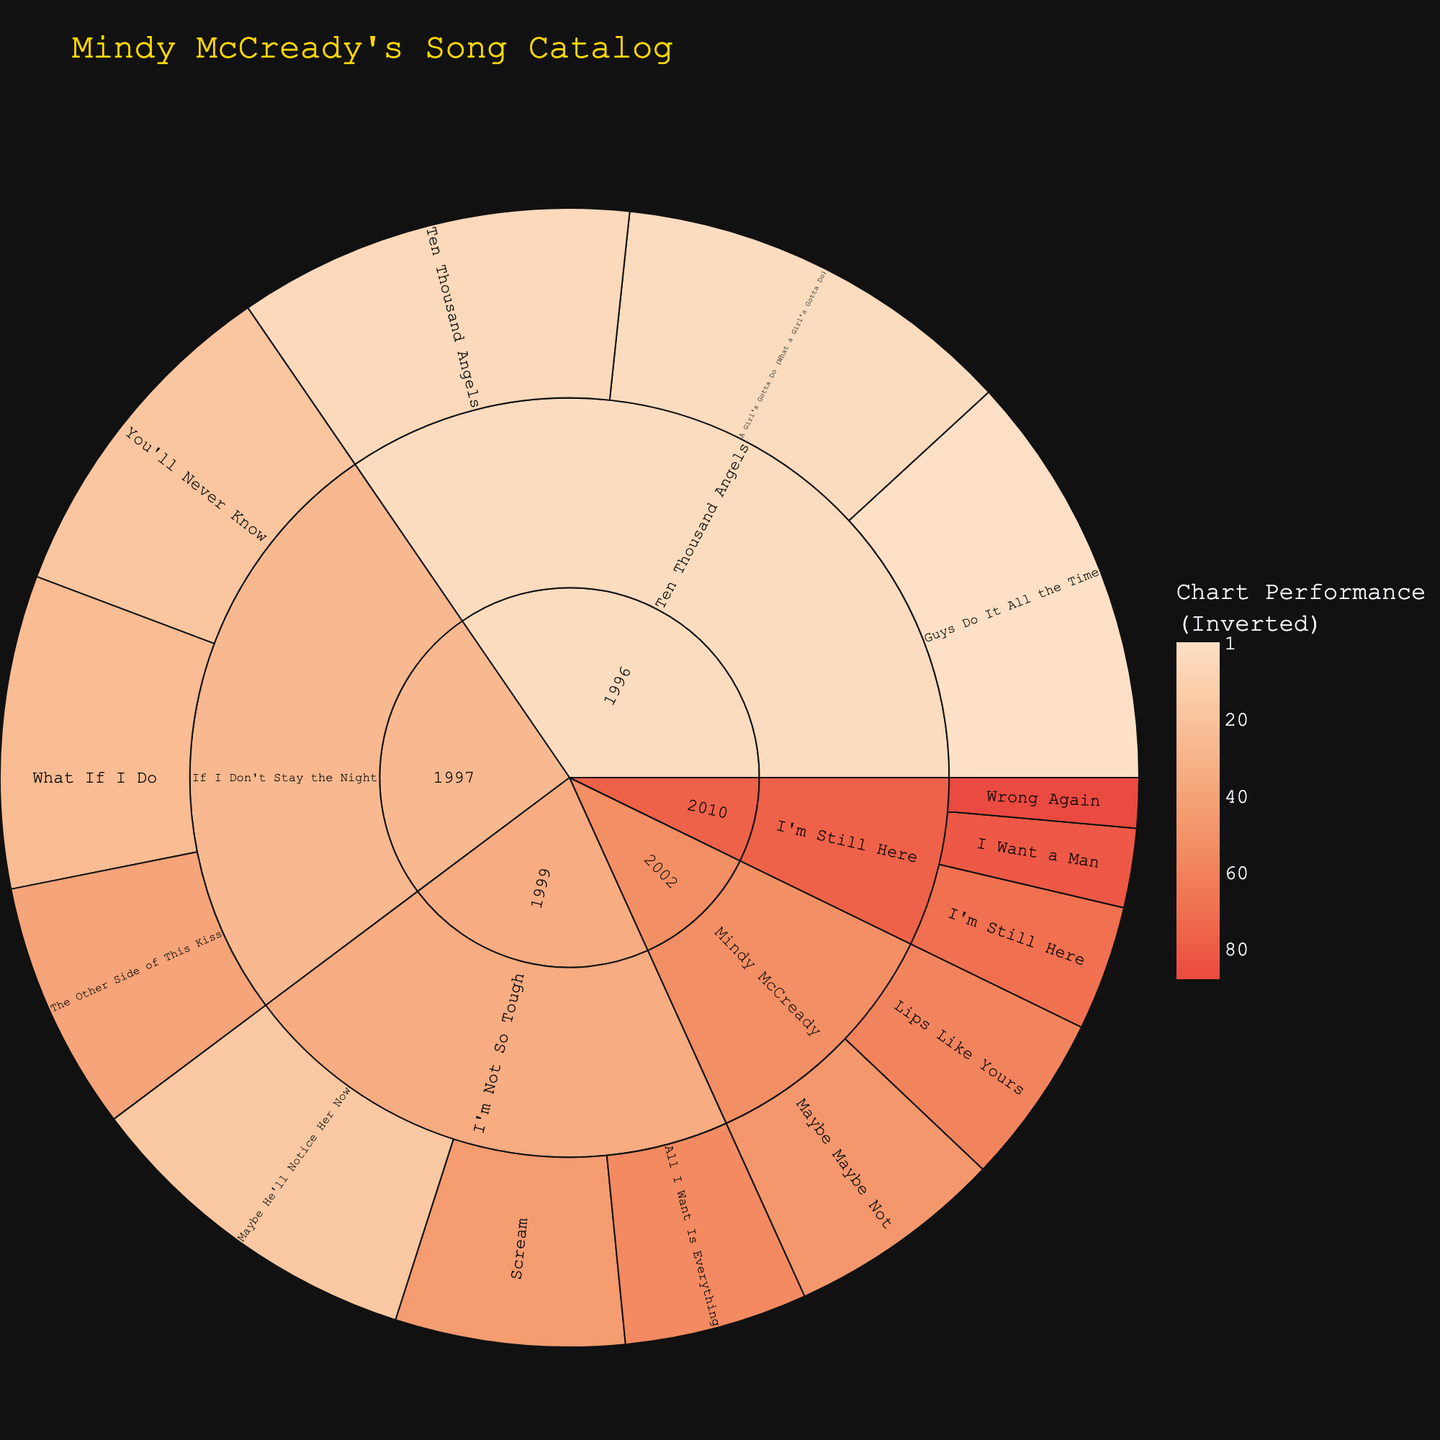What is the title of the sunburst plot? The main title is usually provided at the top of the plot. It summarizes what the visual represents directly. Look at the top of the figure to find this information.
Answer: Mindy McCready's Song Catalog Which album has the highest number of songs listed in the plot? Look at the inner rings of the sunburst to identify which album has the most divisions, indicating the highest number of songs. Compare the segments from different albums.
Answer: Ten Thousand Angels In which release year did Mindy McCready have the song with the highest chart peak? Navigate the innermost ring to find the year, then examine outward to respective albums and songs. Identify the song with the highest chart peak (lowest chart number).
Answer: 1996 Which song from the album "If I Don't Stay the Night" has the lowest chart peak? Find the section for "If I Don't Stay the Night" in the sunburst plot. Traverse the outer layers to look at each song's chart peak and identify the lowest one.
Answer: The Other Side of This Kiss How does the chart performance of songs from the album released in 2002 compare to those from 2010? Locate the sections for the albums released in 2002 and 2010. Compare the chart peak values (hover over individual songs if necessary) for songs within those two years.
Answer: 2002 songs performed better overall What are the chart peak positions of all the songs from the album "I'm Still Here"? Focus on the album "I'm Still Here" and list out the chart peak values provided for each song.
Answer: 71, 82, 89 Which release year had the best average chart performance across all songs? Calculate the average value of the chart peaks for each year segment. Compare the averages to identify the best overall performance.
Answer: 1996 Which song had the highest chart peak from all the albums combined? Identify and compare the individual songs' chart peaks across all albums. Find the lowest numerical peak value, which represents the highest chart position.
Answer: Guys Do It All the Time How many songs from the album "Ten Thousand Angels" charted in the top 10? Navigate to the segment for "Ten Thousand Angels" in the sunburst plot and identify how many songs fall within chart peaks 1 to 10.
Answer: 2 Which song from the album "I'm Not So Tough" performed the best on the charts? Traverse the segment for "I'm Not So Tough" and list the chart peaks of respective songs. Identify the lowest numerical value as the best performance.
Answer: Maybe He'll Notice Her Now 